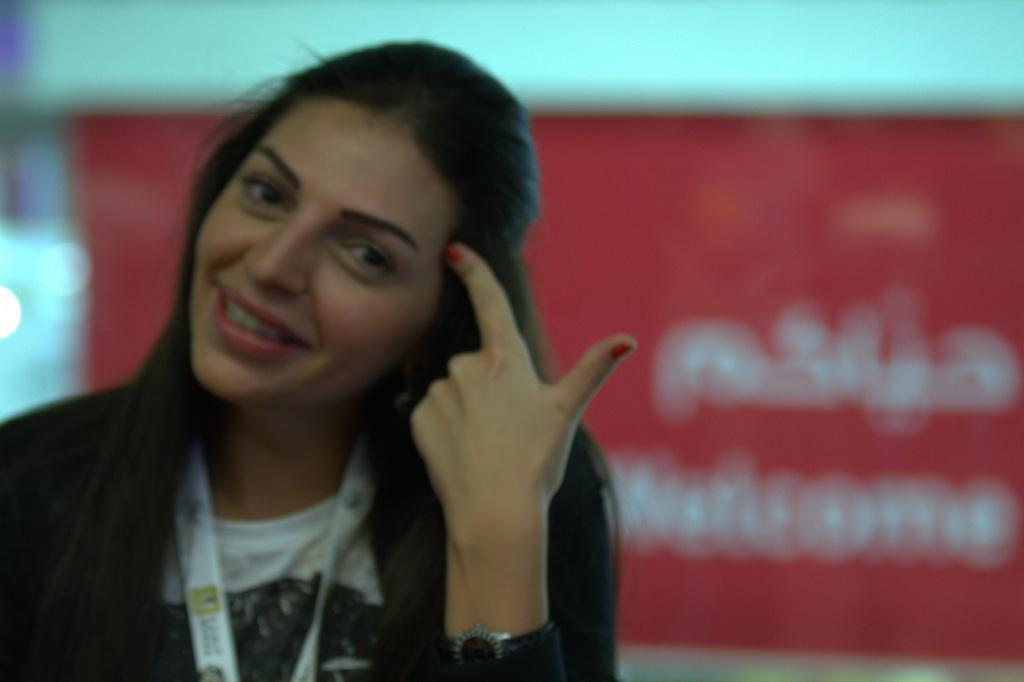Who is the main subject in the image? There is a woman in the image. What is the woman wearing? The woman is wearing a black dress. Can you describe the background of the image? The background of the image is blurred. What else can be seen in the background of the image? There is a banner in the background of the image. What type of star can be seen on the woman's dress in the image? There is no star visible on the woman's dress in the image. What is the woman writing in the image? There is no writing or indication of the woman writing in the image. 